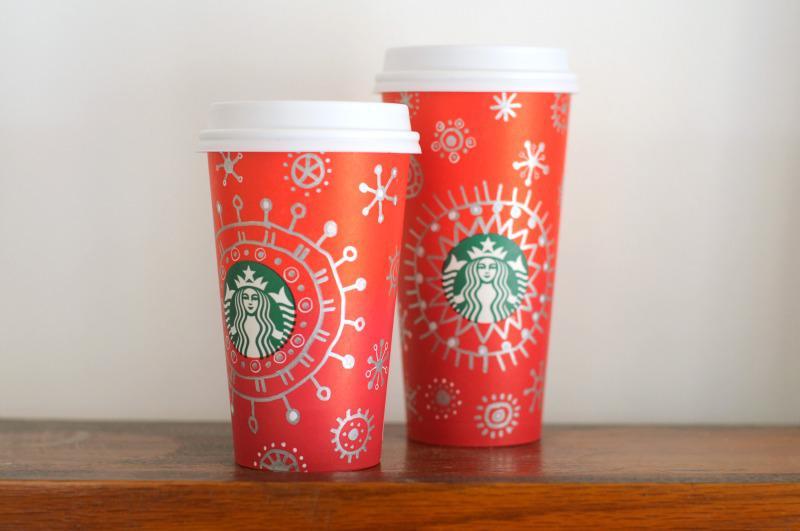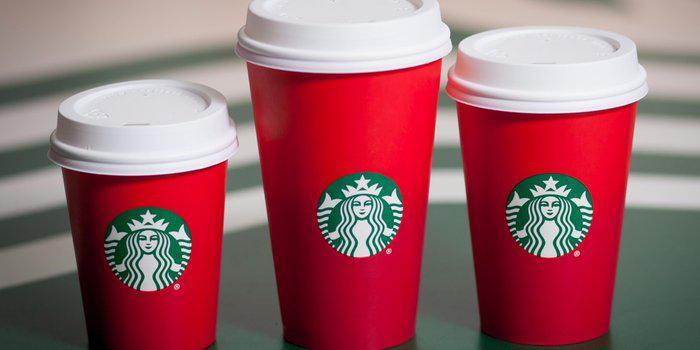The first image is the image on the left, the second image is the image on the right. Given the left and right images, does the statement "There is a total of two red coffee cups." hold true? Answer yes or no. No. The first image is the image on the left, the second image is the image on the right. Evaluate the accuracy of this statement regarding the images: "There are two cups total.". Is it true? Answer yes or no. No. 